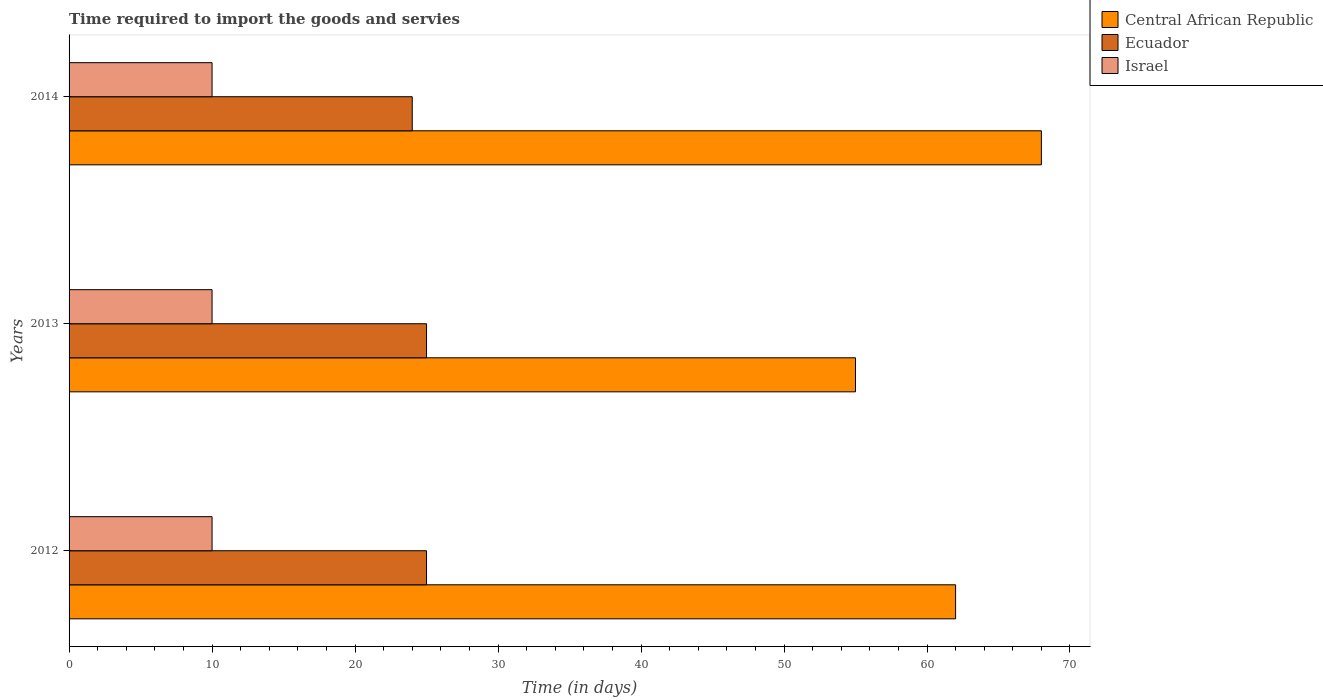How many different coloured bars are there?
Ensure brevity in your answer.  3. How many groups of bars are there?
Provide a succinct answer. 3. Are the number of bars per tick equal to the number of legend labels?
Provide a short and direct response. Yes. Are the number of bars on each tick of the Y-axis equal?
Your answer should be very brief. Yes. How many bars are there on the 1st tick from the top?
Your response must be concise. 3. What is the label of the 2nd group of bars from the top?
Offer a very short reply. 2013. In how many cases, is the number of bars for a given year not equal to the number of legend labels?
Your answer should be very brief. 0. What is the number of days required to import the goods and services in Ecuador in 2013?
Your answer should be very brief. 25. Across all years, what is the maximum number of days required to import the goods and services in Israel?
Ensure brevity in your answer.  10. Across all years, what is the minimum number of days required to import the goods and services in Israel?
Offer a very short reply. 10. In which year was the number of days required to import the goods and services in Ecuador maximum?
Provide a short and direct response. 2012. In which year was the number of days required to import the goods and services in Central African Republic minimum?
Your answer should be very brief. 2013. What is the total number of days required to import the goods and services in Israel in the graph?
Your response must be concise. 30. What is the difference between the number of days required to import the goods and services in Central African Republic in 2013 and that in 2014?
Offer a terse response. -13. What is the difference between the number of days required to import the goods and services in Israel in 2014 and the number of days required to import the goods and services in Central African Republic in 2013?
Offer a terse response. -45. What is the average number of days required to import the goods and services in Israel per year?
Offer a very short reply. 10. In the year 2014, what is the difference between the number of days required to import the goods and services in Central African Republic and number of days required to import the goods and services in Ecuador?
Ensure brevity in your answer.  44. What is the ratio of the number of days required to import the goods and services in Central African Republic in 2013 to that in 2014?
Provide a succinct answer. 0.81. What is the difference between the highest and the lowest number of days required to import the goods and services in Central African Republic?
Your response must be concise. 13. In how many years, is the number of days required to import the goods and services in Israel greater than the average number of days required to import the goods and services in Israel taken over all years?
Make the answer very short. 0. Is the sum of the number of days required to import the goods and services in Ecuador in 2012 and 2014 greater than the maximum number of days required to import the goods and services in Israel across all years?
Offer a very short reply. Yes. What does the 3rd bar from the top in 2013 represents?
Give a very brief answer. Central African Republic. What does the 1st bar from the bottom in 2012 represents?
Provide a succinct answer. Central African Republic. Are all the bars in the graph horizontal?
Make the answer very short. Yes. What is the difference between two consecutive major ticks on the X-axis?
Offer a terse response. 10. Does the graph contain grids?
Provide a succinct answer. No. How are the legend labels stacked?
Give a very brief answer. Vertical. What is the title of the graph?
Make the answer very short. Time required to import the goods and servies. Does "Heavily indebted poor countries" appear as one of the legend labels in the graph?
Provide a succinct answer. No. What is the label or title of the X-axis?
Ensure brevity in your answer.  Time (in days). What is the label or title of the Y-axis?
Your response must be concise. Years. What is the Time (in days) of Central African Republic in 2012?
Make the answer very short. 62. What is the Time (in days) in Ecuador in 2012?
Make the answer very short. 25. What is the Time (in days) in Central African Republic in 2013?
Your answer should be compact. 55. What is the Time (in days) in Ecuador in 2013?
Your answer should be compact. 25. What is the Time (in days) in Israel in 2013?
Keep it short and to the point. 10. What is the Time (in days) in Central African Republic in 2014?
Offer a terse response. 68. What is the Time (in days) of Ecuador in 2014?
Ensure brevity in your answer.  24. Across all years, what is the maximum Time (in days) of Central African Republic?
Give a very brief answer. 68. Across all years, what is the minimum Time (in days) in Ecuador?
Your answer should be compact. 24. What is the total Time (in days) in Central African Republic in the graph?
Keep it short and to the point. 185. What is the difference between the Time (in days) in Ecuador in 2012 and that in 2014?
Offer a very short reply. 1. What is the difference between the Time (in days) in Israel in 2012 and that in 2014?
Your answer should be compact. 0. What is the difference between the Time (in days) of Central African Republic in 2013 and that in 2014?
Ensure brevity in your answer.  -13. What is the difference between the Time (in days) of Ecuador in 2013 and that in 2014?
Your answer should be very brief. 1. What is the difference between the Time (in days) of Central African Republic in 2012 and the Time (in days) of Ecuador in 2013?
Give a very brief answer. 37. What is the difference between the Time (in days) of Central African Republic in 2012 and the Time (in days) of Israel in 2014?
Offer a very short reply. 52. What is the difference between the Time (in days) in Ecuador in 2013 and the Time (in days) in Israel in 2014?
Offer a very short reply. 15. What is the average Time (in days) of Central African Republic per year?
Your answer should be very brief. 61.67. What is the average Time (in days) of Ecuador per year?
Make the answer very short. 24.67. In the year 2012, what is the difference between the Time (in days) in Ecuador and Time (in days) in Israel?
Give a very brief answer. 15. In the year 2013, what is the difference between the Time (in days) of Central African Republic and Time (in days) of Ecuador?
Keep it short and to the point. 30. In the year 2014, what is the difference between the Time (in days) in Ecuador and Time (in days) in Israel?
Your answer should be compact. 14. What is the ratio of the Time (in days) in Central African Republic in 2012 to that in 2013?
Your response must be concise. 1.13. What is the ratio of the Time (in days) of Ecuador in 2012 to that in 2013?
Your answer should be compact. 1. What is the ratio of the Time (in days) of Central African Republic in 2012 to that in 2014?
Give a very brief answer. 0.91. What is the ratio of the Time (in days) of Ecuador in 2012 to that in 2014?
Make the answer very short. 1.04. What is the ratio of the Time (in days) of Israel in 2012 to that in 2014?
Offer a very short reply. 1. What is the ratio of the Time (in days) of Central African Republic in 2013 to that in 2014?
Your answer should be very brief. 0.81. What is the ratio of the Time (in days) in Ecuador in 2013 to that in 2014?
Give a very brief answer. 1.04. What is the difference between the highest and the second highest Time (in days) in Central African Republic?
Offer a very short reply. 6. What is the difference between the highest and the second highest Time (in days) of Ecuador?
Give a very brief answer. 0. What is the difference between the highest and the second highest Time (in days) in Israel?
Your answer should be compact. 0. 